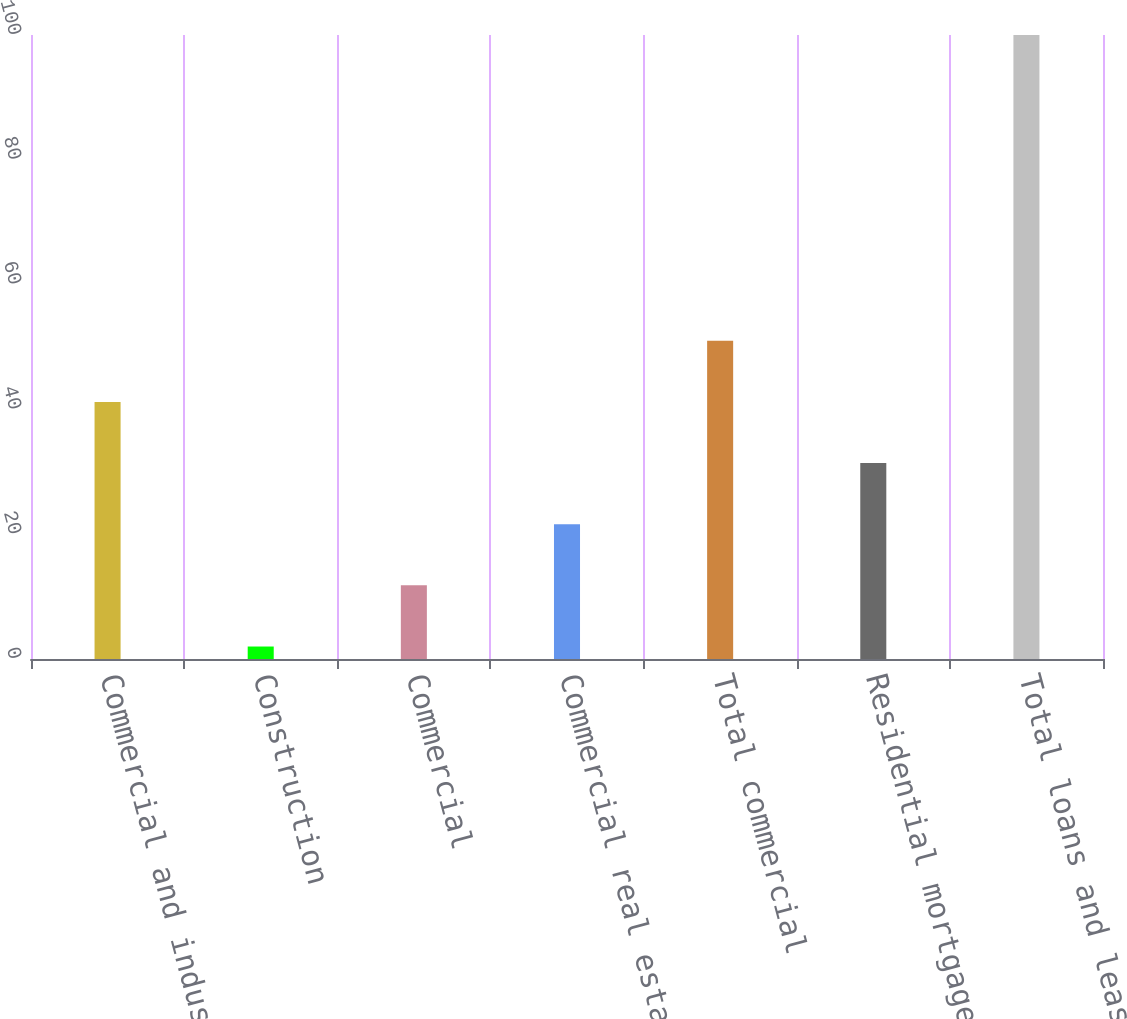<chart> <loc_0><loc_0><loc_500><loc_500><bar_chart><fcel>Commercial and industrial<fcel>Construction<fcel>Commercial<fcel>Commercial real estate<fcel>Total commercial<fcel>Residential mortgage<fcel>Total loans and leases<nl><fcel>41.2<fcel>2<fcel>11.8<fcel>21.6<fcel>51<fcel>31.4<fcel>100<nl></chart> 